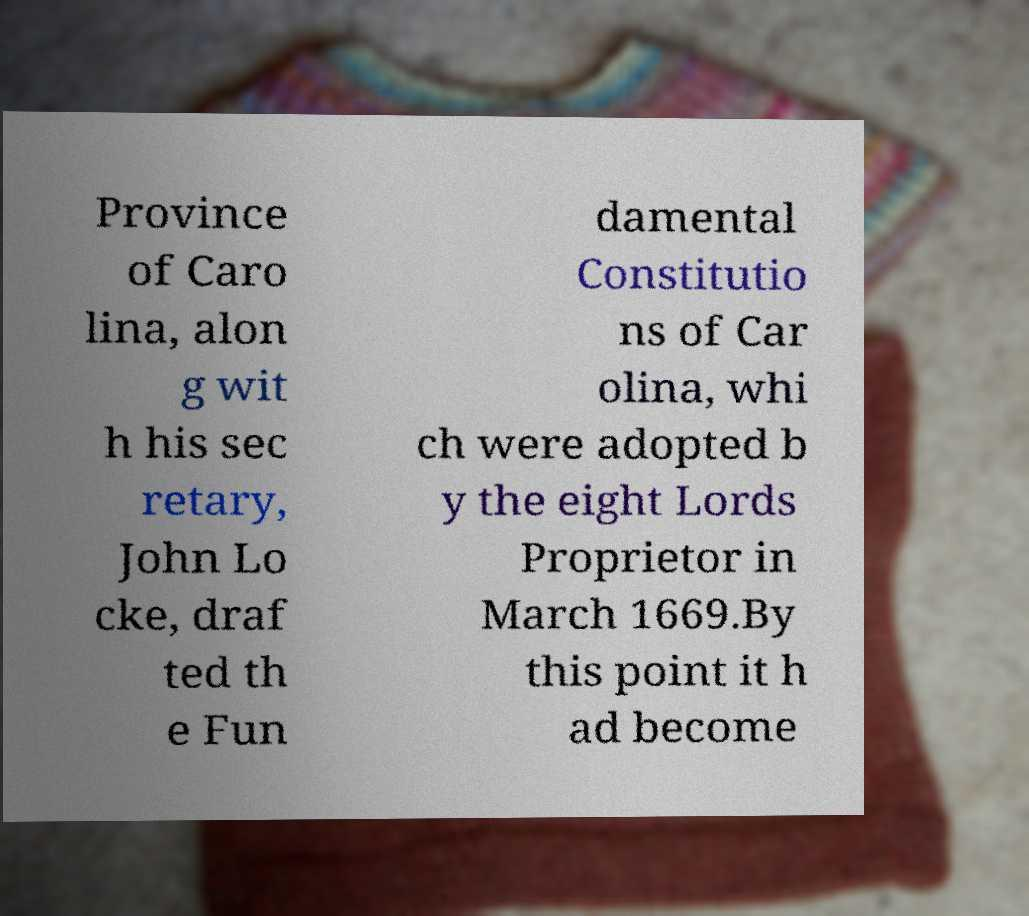There's text embedded in this image that I need extracted. Can you transcribe it verbatim? Province of Caro lina, alon g wit h his sec retary, John Lo cke, draf ted th e Fun damental Constitutio ns of Car olina, whi ch were adopted b y the eight Lords Proprietor in March 1669.By this point it h ad become 